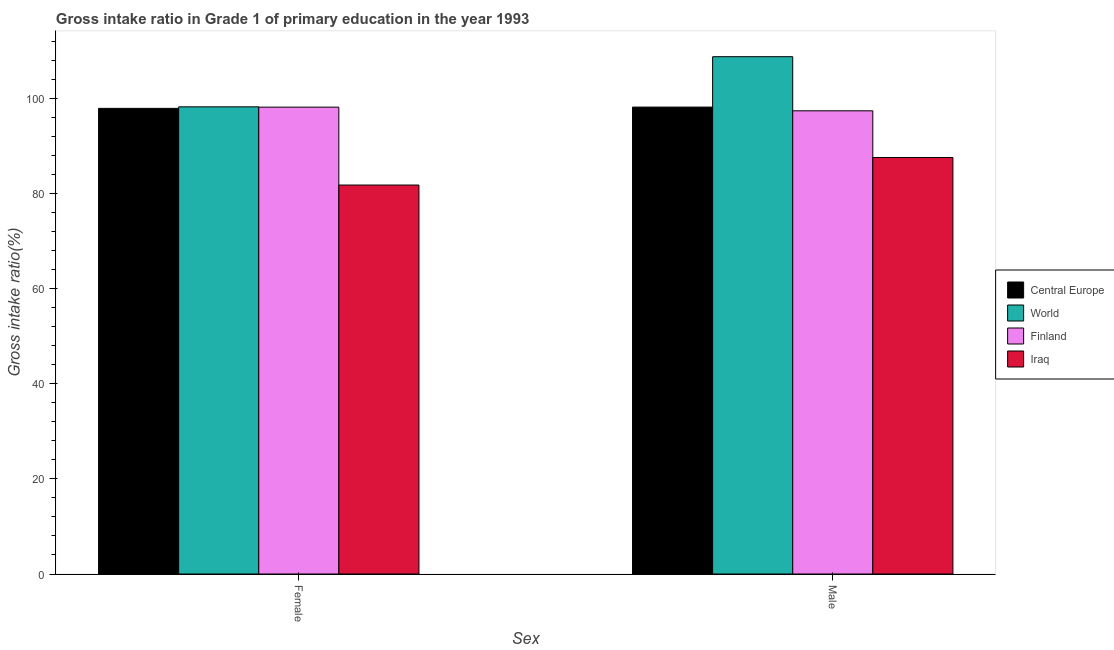How many different coloured bars are there?
Keep it short and to the point. 4. Are the number of bars per tick equal to the number of legend labels?
Provide a succinct answer. Yes. What is the gross intake ratio(male) in Finland?
Your answer should be very brief. 97.44. Across all countries, what is the maximum gross intake ratio(male)?
Keep it short and to the point. 108.83. Across all countries, what is the minimum gross intake ratio(female)?
Give a very brief answer. 81.83. In which country was the gross intake ratio(female) minimum?
Ensure brevity in your answer.  Iraq. What is the total gross intake ratio(female) in the graph?
Provide a short and direct response. 376.27. What is the difference between the gross intake ratio(female) in World and that in Central Europe?
Provide a succinct answer. 0.32. What is the difference between the gross intake ratio(male) in World and the gross intake ratio(female) in Iraq?
Provide a short and direct response. 27. What is the average gross intake ratio(male) per country?
Your answer should be very brief. 98.03. What is the difference between the gross intake ratio(female) and gross intake ratio(male) in World?
Offer a very short reply. -10.55. In how many countries, is the gross intake ratio(female) greater than 44 %?
Give a very brief answer. 4. What is the ratio of the gross intake ratio(female) in World to that in Finland?
Offer a very short reply. 1. What does the 1st bar from the left in Male represents?
Your answer should be compact. Central Europe. Are the values on the major ticks of Y-axis written in scientific E-notation?
Keep it short and to the point. No. Does the graph contain any zero values?
Offer a very short reply. No. Does the graph contain grids?
Your response must be concise. No. How many legend labels are there?
Your response must be concise. 4. What is the title of the graph?
Offer a terse response. Gross intake ratio in Grade 1 of primary education in the year 1993. Does "Armenia" appear as one of the legend labels in the graph?
Give a very brief answer. No. What is the label or title of the X-axis?
Your answer should be compact. Sex. What is the label or title of the Y-axis?
Offer a terse response. Gross intake ratio(%). What is the Gross intake ratio(%) of Central Europe in Female?
Your answer should be compact. 97.95. What is the Gross intake ratio(%) in World in Female?
Offer a terse response. 98.28. What is the Gross intake ratio(%) of Finland in Female?
Offer a very short reply. 98.21. What is the Gross intake ratio(%) of Iraq in Female?
Make the answer very short. 81.83. What is the Gross intake ratio(%) in Central Europe in Male?
Provide a succinct answer. 98.22. What is the Gross intake ratio(%) of World in Male?
Keep it short and to the point. 108.83. What is the Gross intake ratio(%) in Finland in Male?
Provide a succinct answer. 97.44. What is the Gross intake ratio(%) of Iraq in Male?
Provide a succinct answer. 87.62. Across all Sex, what is the maximum Gross intake ratio(%) of Central Europe?
Your response must be concise. 98.22. Across all Sex, what is the maximum Gross intake ratio(%) of World?
Keep it short and to the point. 108.83. Across all Sex, what is the maximum Gross intake ratio(%) in Finland?
Give a very brief answer. 98.21. Across all Sex, what is the maximum Gross intake ratio(%) in Iraq?
Give a very brief answer. 87.62. Across all Sex, what is the minimum Gross intake ratio(%) of Central Europe?
Ensure brevity in your answer.  97.95. Across all Sex, what is the minimum Gross intake ratio(%) in World?
Your response must be concise. 98.28. Across all Sex, what is the minimum Gross intake ratio(%) in Finland?
Your response must be concise. 97.44. Across all Sex, what is the minimum Gross intake ratio(%) of Iraq?
Your answer should be very brief. 81.83. What is the total Gross intake ratio(%) in Central Europe in the graph?
Your response must be concise. 196.18. What is the total Gross intake ratio(%) of World in the graph?
Provide a short and direct response. 207.1. What is the total Gross intake ratio(%) in Finland in the graph?
Provide a succinct answer. 195.65. What is the total Gross intake ratio(%) in Iraq in the graph?
Offer a very short reply. 169.44. What is the difference between the Gross intake ratio(%) in Central Europe in Female and that in Male?
Offer a very short reply. -0.27. What is the difference between the Gross intake ratio(%) in World in Female and that in Male?
Offer a terse response. -10.55. What is the difference between the Gross intake ratio(%) in Finland in Female and that in Male?
Offer a very short reply. 0.77. What is the difference between the Gross intake ratio(%) in Iraq in Female and that in Male?
Offer a very short reply. -5.79. What is the difference between the Gross intake ratio(%) in Central Europe in Female and the Gross intake ratio(%) in World in Male?
Ensure brevity in your answer.  -10.87. What is the difference between the Gross intake ratio(%) in Central Europe in Female and the Gross intake ratio(%) in Finland in Male?
Your answer should be compact. 0.51. What is the difference between the Gross intake ratio(%) in Central Europe in Female and the Gross intake ratio(%) in Iraq in Male?
Offer a very short reply. 10.34. What is the difference between the Gross intake ratio(%) in World in Female and the Gross intake ratio(%) in Finland in Male?
Offer a very short reply. 0.84. What is the difference between the Gross intake ratio(%) of World in Female and the Gross intake ratio(%) of Iraq in Male?
Offer a terse response. 10.66. What is the difference between the Gross intake ratio(%) in Finland in Female and the Gross intake ratio(%) in Iraq in Male?
Your answer should be very brief. 10.6. What is the average Gross intake ratio(%) of Central Europe per Sex?
Make the answer very short. 98.09. What is the average Gross intake ratio(%) of World per Sex?
Give a very brief answer. 103.55. What is the average Gross intake ratio(%) in Finland per Sex?
Offer a very short reply. 97.83. What is the average Gross intake ratio(%) of Iraq per Sex?
Your answer should be very brief. 84.72. What is the difference between the Gross intake ratio(%) of Central Europe and Gross intake ratio(%) of World in Female?
Give a very brief answer. -0.32. What is the difference between the Gross intake ratio(%) in Central Europe and Gross intake ratio(%) in Finland in Female?
Your response must be concise. -0.26. What is the difference between the Gross intake ratio(%) in Central Europe and Gross intake ratio(%) in Iraq in Female?
Give a very brief answer. 16.13. What is the difference between the Gross intake ratio(%) in World and Gross intake ratio(%) in Finland in Female?
Offer a terse response. 0.07. What is the difference between the Gross intake ratio(%) of World and Gross intake ratio(%) of Iraq in Female?
Your response must be concise. 16.45. What is the difference between the Gross intake ratio(%) in Finland and Gross intake ratio(%) in Iraq in Female?
Keep it short and to the point. 16.38. What is the difference between the Gross intake ratio(%) in Central Europe and Gross intake ratio(%) in World in Male?
Your answer should be very brief. -10.6. What is the difference between the Gross intake ratio(%) of Central Europe and Gross intake ratio(%) of Finland in Male?
Provide a succinct answer. 0.78. What is the difference between the Gross intake ratio(%) of Central Europe and Gross intake ratio(%) of Iraq in Male?
Your response must be concise. 10.61. What is the difference between the Gross intake ratio(%) in World and Gross intake ratio(%) in Finland in Male?
Offer a terse response. 11.39. What is the difference between the Gross intake ratio(%) of World and Gross intake ratio(%) of Iraq in Male?
Provide a succinct answer. 21.21. What is the difference between the Gross intake ratio(%) of Finland and Gross intake ratio(%) of Iraq in Male?
Give a very brief answer. 9.82. What is the ratio of the Gross intake ratio(%) of Central Europe in Female to that in Male?
Provide a short and direct response. 1. What is the ratio of the Gross intake ratio(%) of World in Female to that in Male?
Offer a terse response. 0.9. What is the ratio of the Gross intake ratio(%) of Finland in Female to that in Male?
Your response must be concise. 1.01. What is the ratio of the Gross intake ratio(%) of Iraq in Female to that in Male?
Offer a terse response. 0.93. What is the difference between the highest and the second highest Gross intake ratio(%) of Central Europe?
Your response must be concise. 0.27. What is the difference between the highest and the second highest Gross intake ratio(%) in World?
Provide a short and direct response. 10.55. What is the difference between the highest and the second highest Gross intake ratio(%) in Finland?
Your response must be concise. 0.77. What is the difference between the highest and the second highest Gross intake ratio(%) of Iraq?
Your answer should be compact. 5.79. What is the difference between the highest and the lowest Gross intake ratio(%) in Central Europe?
Your answer should be compact. 0.27. What is the difference between the highest and the lowest Gross intake ratio(%) of World?
Keep it short and to the point. 10.55. What is the difference between the highest and the lowest Gross intake ratio(%) of Finland?
Your answer should be very brief. 0.77. What is the difference between the highest and the lowest Gross intake ratio(%) in Iraq?
Provide a short and direct response. 5.79. 